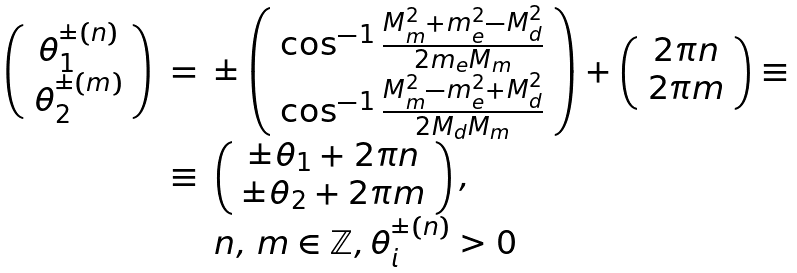<formula> <loc_0><loc_0><loc_500><loc_500>\begin{array} { l l l l l l l } \left ( \begin{array} { c } \theta _ { 1 } ^ { \pm ( n ) } \\ \theta _ { 2 } ^ { \pm ( m ) } \end{array} \right ) & = & \pm \left ( \begin{array} { c } \cos ^ { - 1 } \frac { M _ { m } ^ { 2 } + m _ { e } ^ { 2 } - M _ { d } ^ { 2 } } { 2 m _ { e } M _ { m } } \\ \cos ^ { - 1 } \frac { M _ { m } ^ { 2 } - m _ { e } ^ { 2 } + M _ { d } ^ { 2 } } { 2 M _ { d } M _ { m } } \end{array} \right ) + \left ( \begin{array} { c } 2 \pi n \\ 2 \pi m \end{array} \right ) \equiv \\ & \equiv & \left ( \begin{array} { c } \pm \theta _ { 1 } + 2 \pi n \\ \pm \theta _ { 2 } + 2 \pi m \end{array} \right ) , \\ & & n , \, m \in \mathbb { Z } , \theta _ { i } ^ { \pm ( n ) } > 0 \end{array}</formula> 